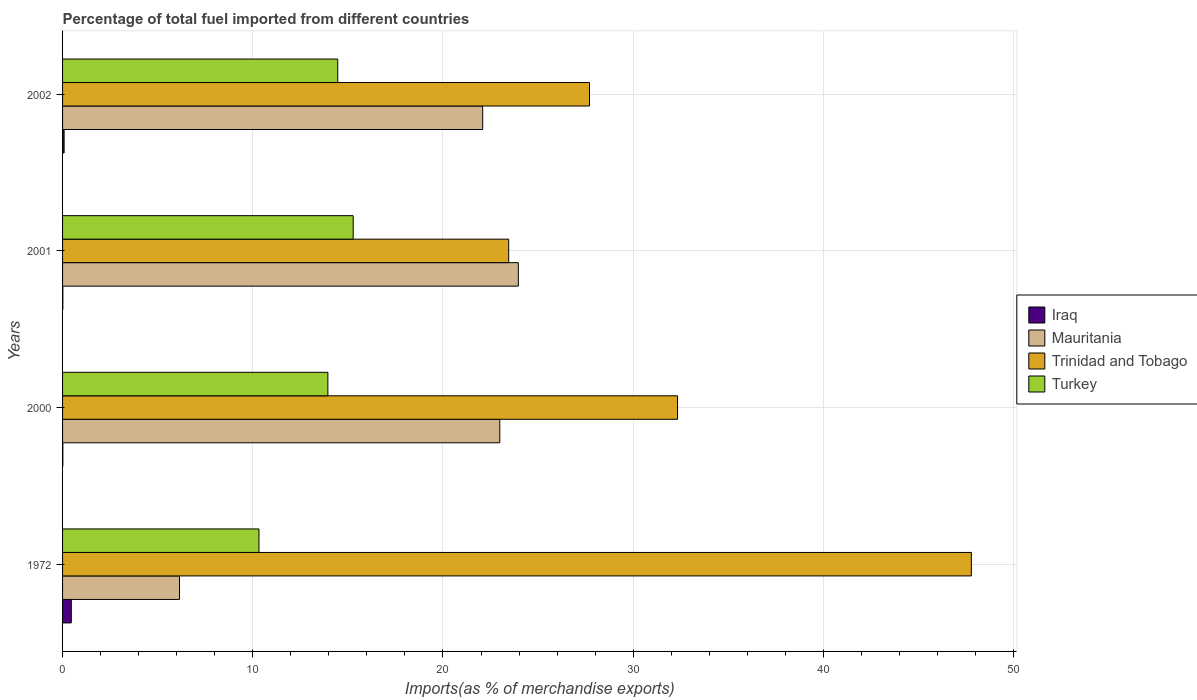How many different coloured bars are there?
Offer a terse response. 4. Are the number of bars per tick equal to the number of legend labels?
Make the answer very short. Yes. Are the number of bars on each tick of the Y-axis equal?
Your answer should be compact. Yes. How many bars are there on the 4th tick from the bottom?
Offer a very short reply. 4. In how many cases, is the number of bars for a given year not equal to the number of legend labels?
Ensure brevity in your answer.  0. What is the percentage of imports to different countries in Mauritania in 2000?
Provide a succinct answer. 22.99. Across all years, what is the maximum percentage of imports to different countries in Iraq?
Ensure brevity in your answer.  0.46. Across all years, what is the minimum percentage of imports to different countries in Iraq?
Offer a very short reply. 0.01. What is the total percentage of imports to different countries in Iraq in the graph?
Your answer should be very brief. 0.57. What is the difference between the percentage of imports to different countries in Turkey in 2000 and that in 2001?
Ensure brevity in your answer.  -1.33. What is the difference between the percentage of imports to different countries in Iraq in 2000 and the percentage of imports to different countries in Trinidad and Tobago in 1972?
Your answer should be very brief. -47.76. What is the average percentage of imports to different countries in Trinidad and Tobago per year?
Make the answer very short. 32.82. In the year 2002, what is the difference between the percentage of imports to different countries in Mauritania and percentage of imports to different countries in Iraq?
Provide a succinct answer. 22.01. In how many years, is the percentage of imports to different countries in Mauritania greater than 4 %?
Provide a short and direct response. 4. What is the ratio of the percentage of imports to different countries in Mauritania in 1972 to that in 2001?
Give a very brief answer. 0.26. Is the percentage of imports to different countries in Iraq in 2001 less than that in 2002?
Ensure brevity in your answer.  Yes. What is the difference between the highest and the second highest percentage of imports to different countries in Iraq?
Make the answer very short. 0.38. What is the difference between the highest and the lowest percentage of imports to different countries in Mauritania?
Keep it short and to the point. 17.81. In how many years, is the percentage of imports to different countries in Mauritania greater than the average percentage of imports to different countries in Mauritania taken over all years?
Keep it short and to the point. 3. Is it the case that in every year, the sum of the percentage of imports to different countries in Mauritania and percentage of imports to different countries in Turkey is greater than the sum of percentage of imports to different countries in Trinidad and Tobago and percentage of imports to different countries in Iraq?
Ensure brevity in your answer.  Yes. What does the 4th bar from the top in 2002 represents?
Give a very brief answer. Iraq. Are all the bars in the graph horizontal?
Make the answer very short. Yes. How many years are there in the graph?
Provide a short and direct response. 4. What is the difference between two consecutive major ticks on the X-axis?
Provide a short and direct response. 10. Are the values on the major ticks of X-axis written in scientific E-notation?
Ensure brevity in your answer.  No. Where does the legend appear in the graph?
Make the answer very short. Center right. How many legend labels are there?
Offer a terse response. 4. What is the title of the graph?
Make the answer very short. Percentage of total fuel imported from different countries. What is the label or title of the X-axis?
Your answer should be very brief. Imports(as % of merchandise exports). What is the label or title of the Y-axis?
Offer a terse response. Years. What is the Imports(as % of merchandise exports) in Iraq in 1972?
Your response must be concise. 0.46. What is the Imports(as % of merchandise exports) of Mauritania in 1972?
Offer a very short reply. 6.15. What is the Imports(as % of merchandise exports) in Trinidad and Tobago in 1972?
Keep it short and to the point. 47.78. What is the Imports(as % of merchandise exports) in Turkey in 1972?
Offer a very short reply. 10.33. What is the Imports(as % of merchandise exports) of Iraq in 2000?
Make the answer very short. 0.01. What is the Imports(as % of merchandise exports) in Mauritania in 2000?
Provide a short and direct response. 22.99. What is the Imports(as % of merchandise exports) of Trinidad and Tobago in 2000?
Offer a very short reply. 32.33. What is the Imports(as % of merchandise exports) of Turkey in 2000?
Your response must be concise. 13.95. What is the Imports(as % of merchandise exports) of Iraq in 2001?
Give a very brief answer. 0.02. What is the Imports(as % of merchandise exports) in Mauritania in 2001?
Provide a succinct answer. 23.96. What is the Imports(as % of merchandise exports) in Trinidad and Tobago in 2001?
Offer a very short reply. 23.46. What is the Imports(as % of merchandise exports) of Turkey in 2001?
Offer a terse response. 15.28. What is the Imports(as % of merchandise exports) of Iraq in 2002?
Offer a very short reply. 0.08. What is the Imports(as % of merchandise exports) of Mauritania in 2002?
Offer a very short reply. 22.09. What is the Imports(as % of merchandise exports) of Trinidad and Tobago in 2002?
Keep it short and to the point. 27.7. What is the Imports(as % of merchandise exports) in Turkey in 2002?
Provide a short and direct response. 14.47. Across all years, what is the maximum Imports(as % of merchandise exports) of Iraq?
Offer a very short reply. 0.46. Across all years, what is the maximum Imports(as % of merchandise exports) of Mauritania?
Provide a succinct answer. 23.96. Across all years, what is the maximum Imports(as % of merchandise exports) in Trinidad and Tobago?
Make the answer very short. 47.78. Across all years, what is the maximum Imports(as % of merchandise exports) in Turkey?
Keep it short and to the point. 15.28. Across all years, what is the minimum Imports(as % of merchandise exports) in Iraq?
Offer a very short reply. 0.01. Across all years, what is the minimum Imports(as % of merchandise exports) of Mauritania?
Give a very brief answer. 6.15. Across all years, what is the minimum Imports(as % of merchandise exports) in Trinidad and Tobago?
Provide a succinct answer. 23.46. Across all years, what is the minimum Imports(as % of merchandise exports) in Turkey?
Your answer should be compact. 10.33. What is the total Imports(as % of merchandise exports) of Iraq in the graph?
Your response must be concise. 0.57. What is the total Imports(as % of merchandise exports) in Mauritania in the graph?
Provide a short and direct response. 75.18. What is the total Imports(as % of merchandise exports) in Trinidad and Tobago in the graph?
Offer a terse response. 131.27. What is the total Imports(as % of merchandise exports) in Turkey in the graph?
Ensure brevity in your answer.  54.02. What is the difference between the Imports(as % of merchandise exports) in Iraq in 1972 and that in 2000?
Keep it short and to the point. 0.44. What is the difference between the Imports(as % of merchandise exports) of Mauritania in 1972 and that in 2000?
Offer a very short reply. -16.84. What is the difference between the Imports(as % of merchandise exports) of Trinidad and Tobago in 1972 and that in 2000?
Offer a very short reply. 15.45. What is the difference between the Imports(as % of merchandise exports) in Turkey in 1972 and that in 2000?
Ensure brevity in your answer.  -3.62. What is the difference between the Imports(as % of merchandise exports) in Iraq in 1972 and that in 2001?
Provide a succinct answer. 0.44. What is the difference between the Imports(as % of merchandise exports) of Mauritania in 1972 and that in 2001?
Your answer should be very brief. -17.81. What is the difference between the Imports(as % of merchandise exports) in Trinidad and Tobago in 1972 and that in 2001?
Provide a succinct answer. 24.32. What is the difference between the Imports(as % of merchandise exports) in Turkey in 1972 and that in 2001?
Offer a very short reply. -4.95. What is the difference between the Imports(as % of merchandise exports) of Iraq in 1972 and that in 2002?
Provide a short and direct response. 0.38. What is the difference between the Imports(as % of merchandise exports) of Mauritania in 1972 and that in 2002?
Offer a very short reply. -15.94. What is the difference between the Imports(as % of merchandise exports) in Trinidad and Tobago in 1972 and that in 2002?
Offer a terse response. 20.08. What is the difference between the Imports(as % of merchandise exports) in Turkey in 1972 and that in 2002?
Provide a short and direct response. -4.14. What is the difference between the Imports(as % of merchandise exports) in Iraq in 2000 and that in 2001?
Provide a short and direct response. -0. What is the difference between the Imports(as % of merchandise exports) of Mauritania in 2000 and that in 2001?
Make the answer very short. -0.97. What is the difference between the Imports(as % of merchandise exports) in Trinidad and Tobago in 2000 and that in 2001?
Ensure brevity in your answer.  8.88. What is the difference between the Imports(as % of merchandise exports) of Turkey in 2000 and that in 2001?
Give a very brief answer. -1.33. What is the difference between the Imports(as % of merchandise exports) in Iraq in 2000 and that in 2002?
Ensure brevity in your answer.  -0.07. What is the difference between the Imports(as % of merchandise exports) of Mauritania in 2000 and that in 2002?
Your answer should be compact. 0.9. What is the difference between the Imports(as % of merchandise exports) in Trinidad and Tobago in 2000 and that in 2002?
Your answer should be very brief. 4.63. What is the difference between the Imports(as % of merchandise exports) of Turkey in 2000 and that in 2002?
Your answer should be very brief. -0.52. What is the difference between the Imports(as % of merchandise exports) in Iraq in 2001 and that in 2002?
Provide a succinct answer. -0.07. What is the difference between the Imports(as % of merchandise exports) of Mauritania in 2001 and that in 2002?
Your answer should be compact. 1.87. What is the difference between the Imports(as % of merchandise exports) of Trinidad and Tobago in 2001 and that in 2002?
Give a very brief answer. -4.25. What is the difference between the Imports(as % of merchandise exports) in Turkey in 2001 and that in 2002?
Provide a succinct answer. 0.81. What is the difference between the Imports(as % of merchandise exports) of Iraq in 1972 and the Imports(as % of merchandise exports) of Mauritania in 2000?
Keep it short and to the point. -22.53. What is the difference between the Imports(as % of merchandise exports) of Iraq in 1972 and the Imports(as % of merchandise exports) of Trinidad and Tobago in 2000?
Provide a succinct answer. -31.87. What is the difference between the Imports(as % of merchandise exports) of Iraq in 1972 and the Imports(as % of merchandise exports) of Turkey in 2000?
Keep it short and to the point. -13.49. What is the difference between the Imports(as % of merchandise exports) of Mauritania in 1972 and the Imports(as % of merchandise exports) of Trinidad and Tobago in 2000?
Your answer should be compact. -26.18. What is the difference between the Imports(as % of merchandise exports) in Mauritania in 1972 and the Imports(as % of merchandise exports) in Turkey in 2000?
Your answer should be very brief. -7.8. What is the difference between the Imports(as % of merchandise exports) of Trinidad and Tobago in 1972 and the Imports(as % of merchandise exports) of Turkey in 2000?
Give a very brief answer. 33.83. What is the difference between the Imports(as % of merchandise exports) of Iraq in 1972 and the Imports(as % of merchandise exports) of Mauritania in 2001?
Offer a terse response. -23.5. What is the difference between the Imports(as % of merchandise exports) of Iraq in 1972 and the Imports(as % of merchandise exports) of Trinidad and Tobago in 2001?
Make the answer very short. -23. What is the difference between the Imports(as % of merchandise exports) in Iraq in 1972 and the Imports(as % of merchandise exports) in Turkey in 2001?
Ensure brevity in your answer.  -14.82. What is the difference between the Imports(as % of merchandise exports) in Mauritania in 1972 and the Imports(as % of merchandise exports) in Trinidad and Tobago in 2001?
Provide a short and direct response. -17.31. What is the difference between the Imports(as % of merchandise exports) of Mauritania in 1972 and the Imports(as % of merchandise exports) of Turkey in 2001?
Offer a terse response. -9.13. What is the difference between the Imports(as % of merchandise exports) in Trinidad and Tobago in 1972 and the Imports(as % of merchandise exports) in Turkey in 2001?
Your response must be concise. 32.5. What is the difference between the Imports(as % of merchandise exports) of Iraq in 1972 and the Imports(as % of merchandise exports) of Mauritania in 2002?
Provide a short and direct response. -21.63. What is the difference between the Imports(as % of merchandise exports) in Iraq in 1972 and the Imports(as % of merchandise exports) in Trinidad and Tobago in 2002?
Your response must be concise. -27.24. What is the difference between the Imports(as % of merchandise exports) of Iraq in 1972 and the Imports(as % of merchandise exports) of Turkey in 2002?
Provide a short and direct response. -14.01. What is the difference between the Imports(as % of merchandise exports) in Mauritania in 1972 and the Imports(as % of merchandise exports) in Trinidad and Tobago in 2002?
Offer a very short reply. -21.55. What is the difference between the Imports(as % of merchandise exports) of Mauritania in 1972 and the Imports(as % of merchandise exports) of Turkey in 2002?
Offer a terse response. -8.32. What is the difference between the Imports(as % of merchandise exports) in Trinidad and Tobago in 1972 and the Imports(as % of merchandise exports) in Turkey in 2002?
Ensure brevity in your answer.  33.31. What is the difference between the Imports(as % of merchandise exports) of Iraq in 2000 and the Imports(as % of merchandise exports) of Mauritania in 2001?
Make the answer very short. -23.95. What is the difference between the Imports(as % of merchandise exports) of Iraq in 2000 and the Imports(as % of merchandise exports) of Trinidad and Tobago in 2001?
Make the answer very short. -23.44. What is the difference between the Imports(as % of merchandise exports) of Iraq in 2000 and the Imports(as % of merchandise exports) of Turkey in 2001?
Offer a very short reply. -15.26. What is the difference between the Imports(as % of merchandise exports) in Mauritania in 2000 and the Imports(as % of merchandise exports) in Trinidad and Tobago in 2001?
Keep it short and to the point. -0.47. What is the difference between the Imports(as % of merchandise exports) in Mauritania in 2000 and the Imports(as % of merchandise exports) in Turkey in 2001?
Keep it short and to the point. 7.71. What is the difference between the Imports(as % of merchandise exports) in Trinidad and Tobago in 2000 and the Imports(as % of merchandise exports) in Turkey in 2001?
Your answer should be compact. 17.05. What is the difference between the Imports(as % of merchandise exports) in Iraq in 2000 and the Imports(as % of merchandise exports) in Mauritania in 2002?
Make the answer very short. -22.07. What is the difference between the Imports(as % of merchandise exports) of Iraq in 2000 and the Imports(as % of merchandise exports) of Trinidad and Tobago in 2002?
Your response must be concise. -27.69. What is the difference between the Imports(as % of merchandise exports) in Iraq in 2000 and the Imports(as % of merchandise exports) in Turkey in 2002?
Offer a very short reply. -14.45. What is the difference between the Imports(as % of merchandise exports) in Mauritania in 2000 and the Imports(as % of merchandise exports) in Trinidad and Tobago in 2002?
Offer a very short reply. -4.72. What is the difference between the Imports(as % of merchandise exports) in Mauritania in 2000 and the Imports(as % of merchandise exports) in Turkey in 2002?
Keep it short and to the point. 8.52. What is the difference between the Imports(as % of merchandise exports) of Trinidad and Tobago in 2000 and the Imports(as % of merchandise exports) of Turkey in 2002?
Ensure brevity in your answer.  17.86. What is the difference between the Imports(as % of merchandise exports) in Iraq in 2001 and the Imports(as % of merchandise exports) in Mauritania in 2002?
Keep it short and to the point. -22.07. What is the difference between the Imports(as % of merchandise exports) in Iraq in 2001 and the Imports(as % of merchandise exports) in Trinidad and Tobago in 2002?
Ensure brevity in your answer.  -27.69. What is the difference between the Imports(as % of merchandise exports) in Iraq in 2001 and the Imports(as % of merchandise exports) in Turkey in 2002?
Give a very brief answer. -14.45. What is the difference between the Imports(as % of merchandise exports) in Mauritania in 2001 and the Imports(as % of merchandise exports) in Trinidad and Tobago in 2002?
Provide a succinct answer. -3.74. What is the difference between the Imports(as % of merchandise exports) in Mauritania in 2001 and the Imports(as % of merchandise exports) in Turkey in 2002?
Give a very brief answer. 9.49. What is the difference between the Imports(as % of merchandise exports) of Trinidad and Tobago in 2001 and the Imports(as % of merchandise exports) of Turkey in 2002?
Offer a terse response. 8.99. What is the average Imports(as % of merchandise exports) of Iraq per year?
Ensure brevity in your answer.  0.14. What is the average Imports(as % of merchandise exports) in Mauritania per year?
Your answer should be very brief. 18.8. What is the average Imports(as % of merchandise exports) in Trinidad and Tobago per year?
Your answer should be very brief. 32.82. What is the average Imports(as % of merchandise exports) in Turkey per year?
Keep it short and to the point. 13.51. In the year 1972, what is the difference between the Imports(as % of merchandise exports) in Iraq and Imports(as % of merchandise exports) in Mauritania?
Offer a very short reply. -5.69. In the year 1972, what is the difference between the Imports(as % of merchandise exports) in Iraq and Imports(as % of merchandise exports) in Trinidad and Tobago?
Give a very brief answer. -47.32. In the year 1972, what is the difference between the Imports(as % of merchandise exports) in Iraq and Imports(as % of merchandise exports) in Turkey?
Your answer should be very brief. -9.87. In the year 1972, what is the difference between the Imports(as % of merchandise exports) in Mauritania and Imports(as % of merchandise exports) in Trinidad and Tobago?
Make the answer very short. -41.63. In the year 1972, what is the difference between the Imports(as % of merchandise exports) in Mauritania and Imports(as % of merchandise exports) in Turkey?
Your answer should be very brief. -4.18. In the year 1972, what is the difference between the Imports(as % of merchandise exports) in Trinidad and Tobago and Imports(as % of merchandise exports) in Turkey?
Ensure brevity in your answer.  37.45. In the year 2000, what is the difference between the Imports(as % of merchandise exports) in Iraq and Imports(as % of merchandise exports) in Mauritania?
Your answer should be very brief. -22.97. In the year 2000, what is the difference between the Imports(as % of merchandise exports) of Iraq and Imports(as % of merchandise exports) of Trinidad and Tobago?
Provide a succinct answer. -32.32. In the year 2000, what is the difference between the Imports(as % of merchandise exports) of Iraq and Imports(as % of merchandise exports) of Turkey?
Provide a succinct answer. -13.93. In the year 2000, what is the difference between the Imports(as % of merchandise exports) in Mauritania and Imports(as % of merchandise exports) in Trinidad and Tobago?
Keep it short and to the point. -9.35. In the year 2000, what is the difference between the Imports(as % of merchandise exports) in Mauritania and Imports(as % of merchandise exports) in Turkey?
Ensure brevity in your answer.  9.04. In the year 2000, what is the difference between the Imports(as % of merchandise exports) in Trinidad and Tobago and Imports(as % of merchandise exports) in Turkey?
Keep it short and to the point. 18.38. In the year 2001, what is the difference between the Imports(as % of merchandise exports) of Iraq and Imports(as % of merchandise exports) of Mauritania?
Offer a terse response. -23.95. In the year 2001, what is the difference between the Imports(as % of merchandise exports) of Iraq and Imports(as % of merchandise exports) of Trinidad and Tobago?
Provide a short and direct response. -23.44. In the year 2001, what is the difference between the Imports(as % of merchandise exports) of Iraq and Imports(as % of merchandise exports) of Turkey?
Keep it short and to the point. -15.26. In the year 2001, what is the difference between the Imports(as % of merchandise exports) in Mauritania and Imports(as % of merchandise exports) in Trinidad and Tobago?
Offer a very short reply. 0.51. In the year 2001, what is the difference between the Imports(as % of merchandise exports) in Mauritania and Imports(as % of merchandise exports) in Turkey?
Provide a short and direct response. 8.68. In the year 2001, what is the difference between the Imports(as % of merchandise exports) in Trinidad and Tobago and Imports(as % of merchandise exports) in Turkey?
Offer a terse response. 8.18. In the year 2002, what is the difference between the Imports(as % of merchandise exports) in Iraq and Imports(as % of merchandise exports) in Mauritania?
Your answer should be compact. -22.01. In the year 2002, what is the difference between the Imports(as % of merchandise exports) of Iraq and Imports(as % of merchandise exports) of Trinidad and Tobago?
Provide a succinct answer. -27.62. In the year 2002, what is the difference between the Imports(as % of merchandise exports) of Iraq and Imports(as % of merchandise exports) of Turkey?
Provide a succinct answer. -14.39. In the year 2002, what is the difference between the Imports(as % of merchandise exports) of Mauritania and Imports(as % of merchandise exports) of Trinidad and Tobago?
Provide a short and direct response. -5.61. In the year 2002, what is the difference between the Imports(as % of merchandise exports) of Mauritania and Imports(as % of merchandise exports) of Turkey?
Provide a short and direct response. 7.62. In the year 2002, what is the difference between the Imports(as % of merchandise exports) of Trinidad and Tobago and Imports(as % of merchandise exports) of Turkey?
Your response must be concise. 13.23. What is the ratio of the Imports(as % of merchandise exports) in Iraq in 1972 to that in 2000?
Your response must be concise. 30.79. What is the ratio of the Imports(as % of merchandise exports) in Mauritania in 1972 to that in 2000?
Your answer should be very brief. 0.27. What is the ratio of the Imports(as % of merchandise exports) of Trinidad and Tobago in 1972 to that in 2000?
Keep it short and to the point. 1.48. What is the ratio of the Imports(as % of merchandise exports) in Turkey in 1972 to that in 2000?
Your answer should be compact. 0.74. What is the ratio of the Imports(as % of merchandise exports) in Iraq in 1972 to that in 2001?
Provide a succinct answer. 29.54. What is the ratio of the Imports(as % of merchandise exports) of Mauritania in 1972 to that in 2001?
Make the answer very short. 0.26. What is the ratio of the Imports(as % of merchandise exports) of Trinidad and Tobago in 1972 to that in 2001?
Keep it short and to the point. 2.04. What is the ratio of the Imports(as % of merchandise exports) of Turkey in 1972 to that in 2001?
Provide a succinct answer. 0.68. What is the ratio of the Imports(as % of merchandise exports) of Iraq in 1972 to that in 2002?
Ensure brevity in your answer.  5.63. What is the ratio of the Imports(as % of merchandise exports) of Mauritania in 1972 to that in 2002?
Offer a terse response. 0.28. What is the ratio of the Imports(as % of merchandise exports) of Trinidad and Tobago in 1972 to that in 2002?
Your response must be concise. 1.72. What is the ratio of the Imports(as % of merchandise exports) of Turkey in 1972 to that in 2002?
Offer a terse response. 0.71. What is the ratio of the Imports(as % of merchandise exports) of Iraq in 2000 to that in 2001?
Keep it short and to the point. 0.96. What is the ratio of the Imports(as % of merchandise exports) of Mauritania in 2000 to that in 2001?
Provide a succinct answer. 0.96. What is the ratio of the Imports(as % of merchandise exports) in Trinidad and Tobago in 2000 to that in 2001?
Give a very brief answer. 1.38. What is the ratio of the Imports(as % of merchandise exports) in Turkey in 2000 to that in 2001?
Your answer should be very brief. 0.91. What is the ratio of the Imports(as % of merchandise exports) of Iraq in 2000 to that in 2002?
Ensure brevity in your answer.  0.18. What is the ratio of the Imports(as % of merchandise exports) of Mauritania in 2000 to that in 2002?
Ensure brevity in your answer.  1.04. What is the ratio of the Imports(as % of merchandise exports) of Trinidad and Tobago in 2000 to that in 2002?
Provide a succinct answer. 1.17. What is the ratio of the Imports(as % of merchandise exports) of Turkey in 2000 to that in 2002?
Your answer should be compact. 0.96. What is the ratio of the Imports(as % of merchandise exports) in Iraq in 2001 to that in 2002?
Keep it short and to the point. 0.19. What is the ratio of the Imports(as % of merchandise exports) in Mauritania in 2001 to that in 2002?
Offer a terse response. 1.08. What is the ratio of the Imports(as % of merchandise exports) in Trinidad and Tobago in 2001 to that in 2002?
Your response must be concise. 0.85. What is the ratio of the Imports(as % of merchandise exports) of Turkey in 2001 to that in 2002?
Ensure brevity in your answer.  1.06. What is the difference between the highest and the second highest Imports(as % of merchandise exports) of Iraq?
Give a very brief answer. 0.38. What is the difference between the highest and the second highest Imports(as % of merchandise exports) of Mauritania?
Provide a short and direct response. 0.97. What is the difference between the highest and the second highest Imports(as % of merchandise exports) in Trinidad and Tobago?
Give a very brief answer. 15.45. What is the difference between the highest and the second highest Imports(as % of merchandise exports) of Turkey?
Keep it short and to the point. 0.81. What is the difference between the highest and the lowest Imports(as % of merchandise exports) of Iraq?
Give a very brief answer. 0.44. What is the difference between the highest and the lowest Imports(as % of merchandise exports) in Mauritania?
Your response must be concise. 17.81. What is the difference between the highest and the lowest Imports(as % of merchandise exports) of Trinidad and Tobago?
Provide a succinct answer. 24.32. What is the difference between the highest and the lowest Imports(as % of merchandise exports) in Turkey?
Keep it short and to the point. 4.95. 